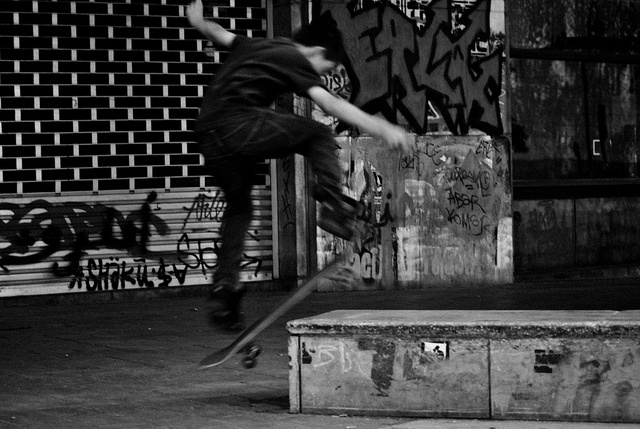Describe the objects in this image and their specific colors. I can see people in black, gray, darkgray, and lightgray tones and skateboard in black and gray tones in this image. 